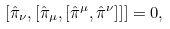<formula> <loc_0><loc_0><loc_500><loc_500>[ \hat { \pi } _ { \nu } , [ \hat { \pi } _ { \mu } , [ \hat { \pi } ^ { \mu } , \hat { \pi } ^ { \nu } ] ] ] = 0 ,</formula> 